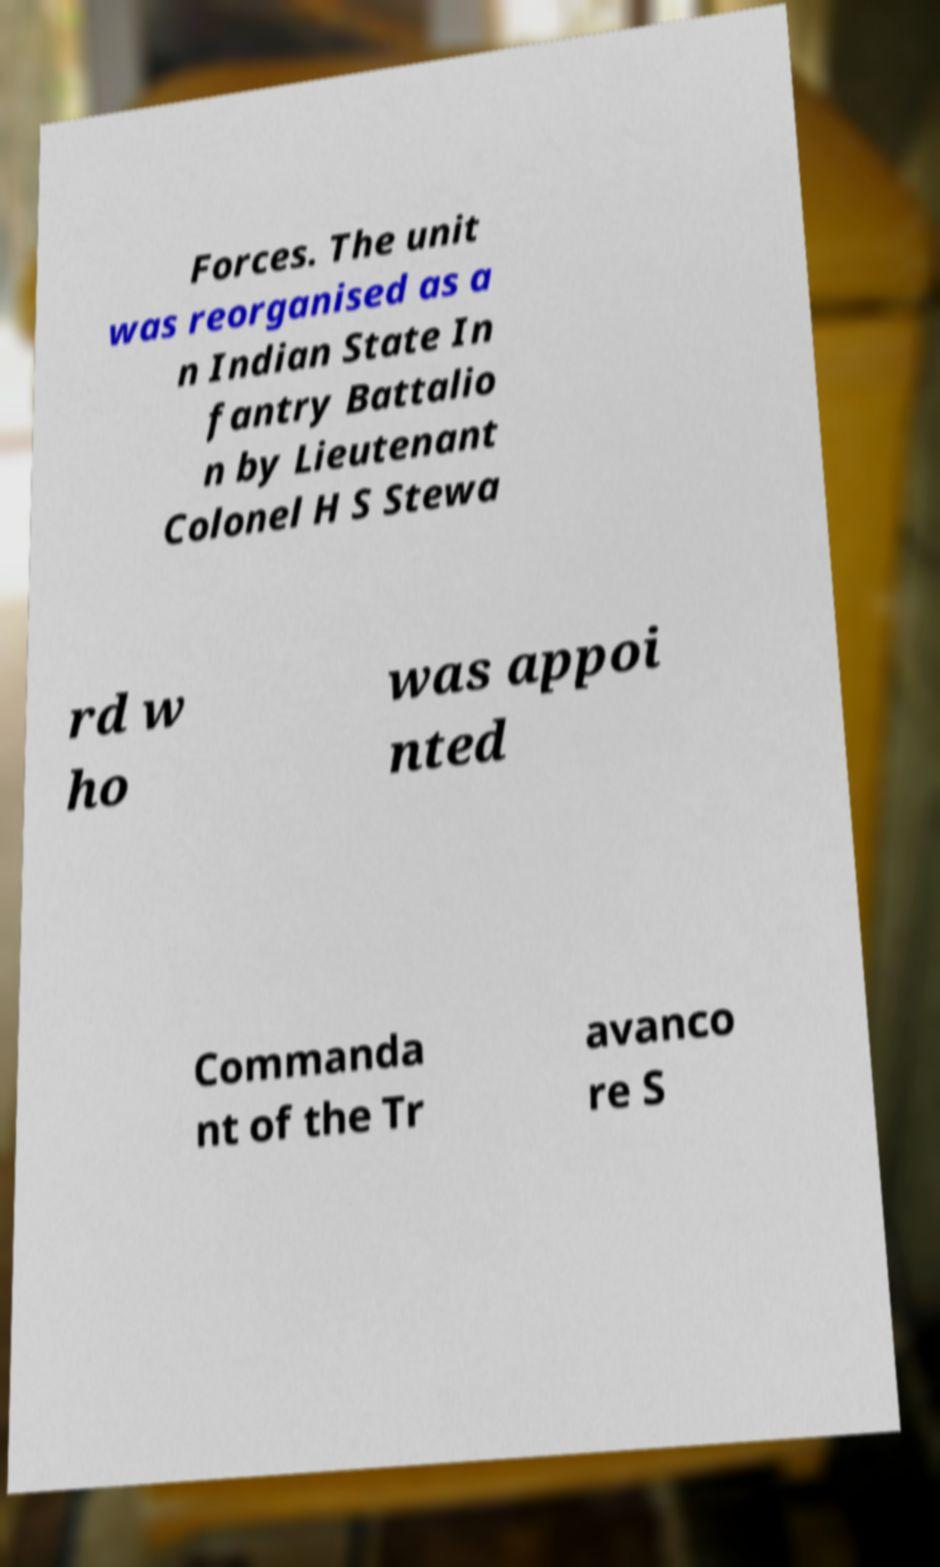Can you read and provide the text displayed in the image?This photo seems to have some interesting text. Can you extract and type it out for me? Forces. The unit was reorganised as a n Indian State In fantry Battalio n by Lieutenant Colonel H S Stewa rd w ho was appoi nted Commanda nt of the Tr avanco re S 